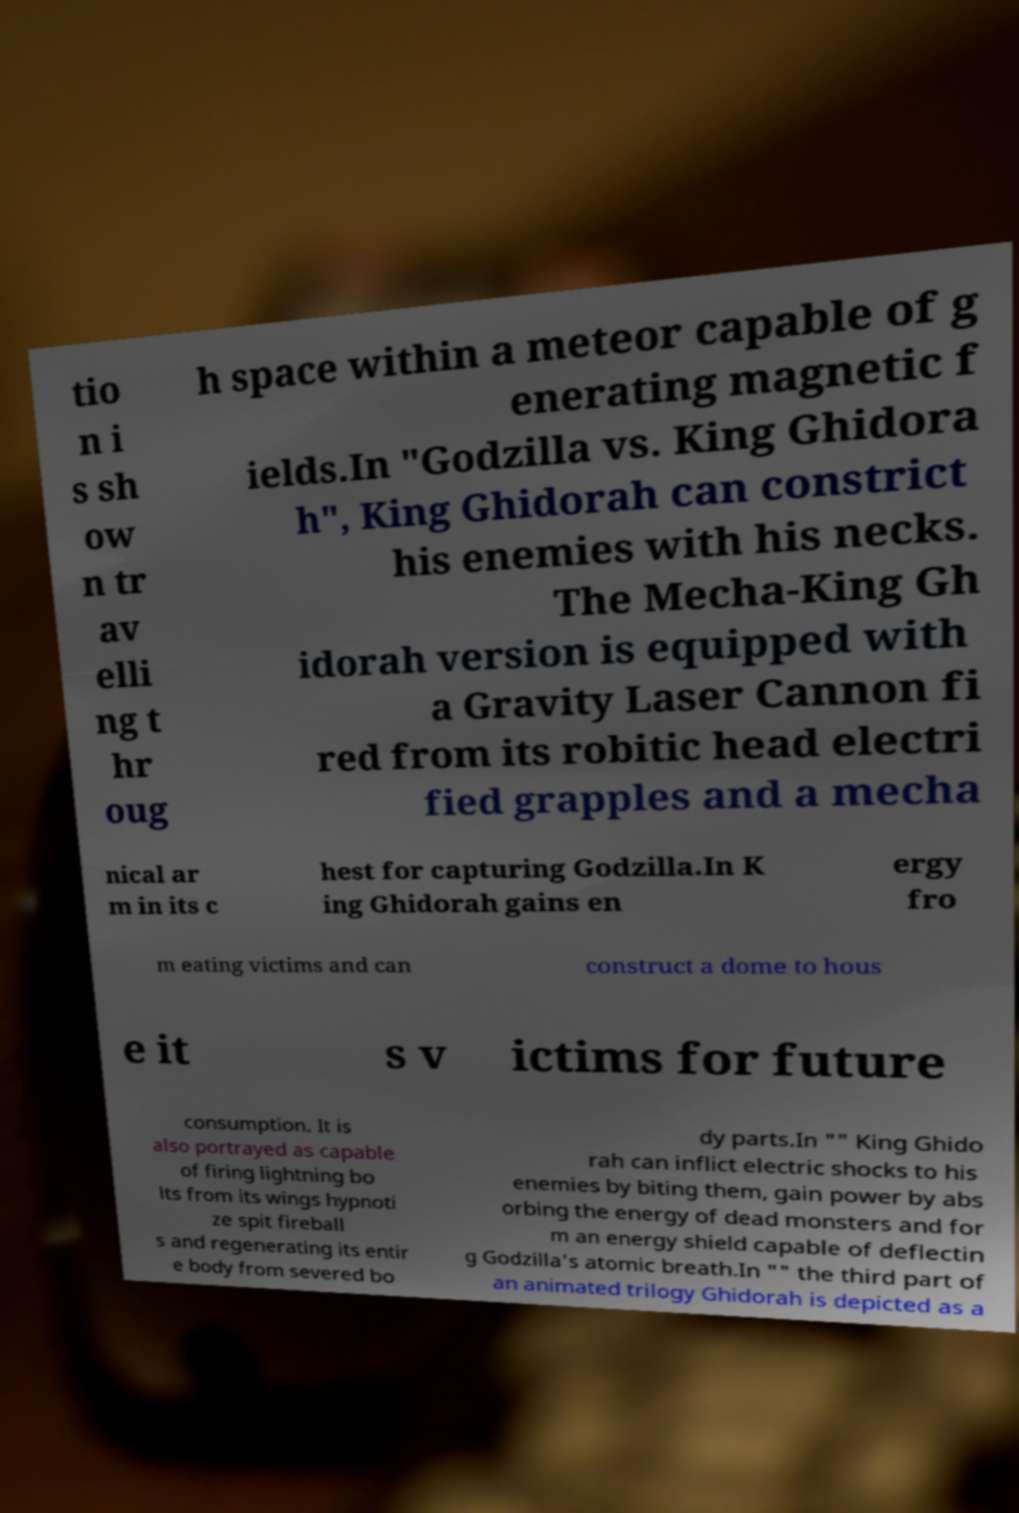What messages or text are displayed in this image? I need them in a readable, typed format. tio n i s sh ow n tr av elli ng t hr oug h space within a meteor capable of g enerating magnetic f ields.In "Godzilla vs. King Ghidora h", King Ghidorah can constrict his enemies with his necks. The Mecha-King Gh idorah version is equipped with a Gravity Laser Cannon fi red from its robitic head electri fied grapples and a mecha nical ar m in its c hest for capturing Godzilla.In K ing Ghidorah gains en ergy fro m eating victims and can construct a dome to hous e it s v ictims for future consumption. It is also portrayed as capable of firing lightning bo lts from its wings hypnoti ze spit fireball s and regenerating its entir e body from severed bo dy parts.In "" King Ghido rah can inflict electric shocks to his enemies by biting them, gain power by abs orbing the energy of dead monsters and for m an energy shield capable of deflectin g Godzilla's atomic breath.In "" the third part of an animated trilogy Ghidorah is depicted as a 